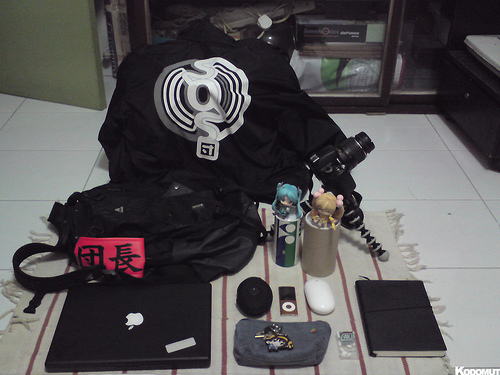<image>
Is the soap on the book? No. The soap is not positioned on the book. They may be near each other, but the soap is not supported by or resting on top of the book. 